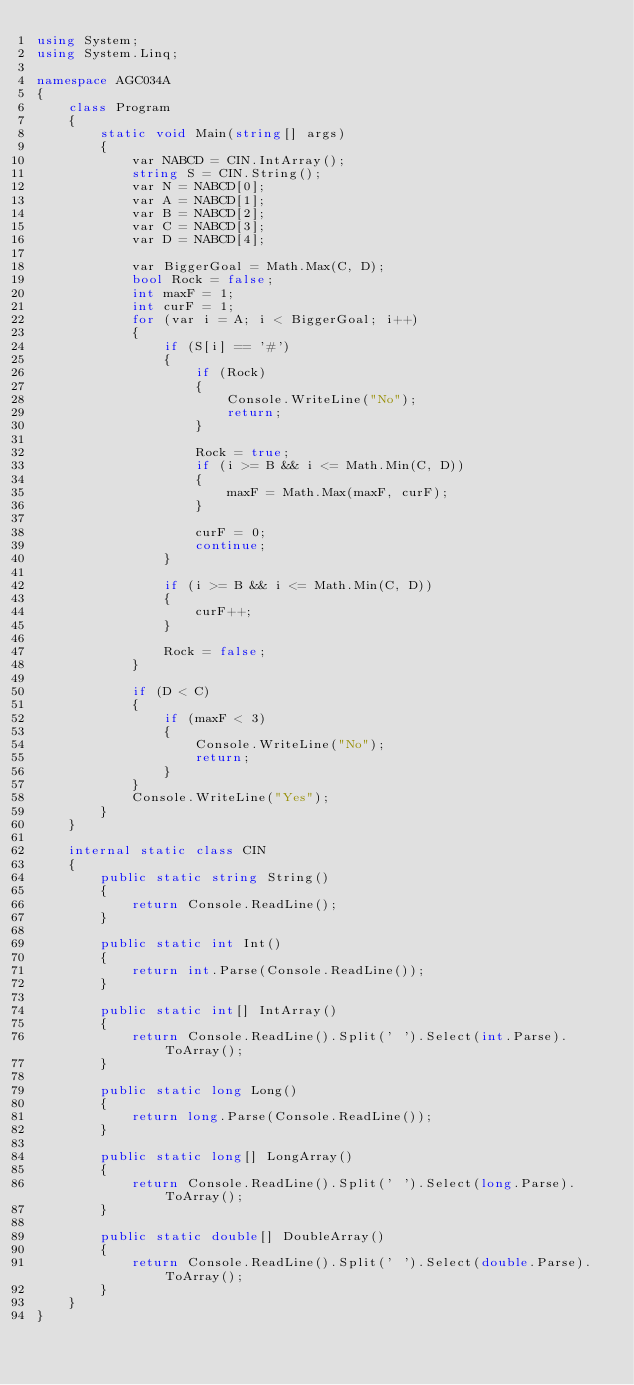Convert code to text. <code><loc_0><loc_0><loc_500><loc_500><_C#_>using System;
using System.Linq;

namespace AGC034A
{
    class Program
    {
        static void Main(string[] args)
        {
            var NABCD = CIN.IntArray();
            string S = CIN.String();
            var N = NABCD[0];
            var A = NABCD[1];
            var B = NABCD[2];
            var C = NABCD[3];
            var D = NABCD[4];

            var BiggerGoal = Math.Max(C, D);
            bool Rock = false;
            int maxF = 1;
            int curF = 1;
            for (var i = A; i < BiggerGoal; i++)
            {
                if (S[i] == '#')
                {
                    if (Rock)
                    {
                        Console.WriteLine("No");
                        return;
                    }

                    Rock = true;
                    if (i >= B && i <= Math.Min(C, D))
                    {
                        maxF = Math.Max(maxF, curF);
                    }

                    curF = 0;
                    continue;
                }

                if (i >= B && i <= Math.Min(C, D))
                {
                    curF++;
                }

                Rock = false;
            }

            if (D < C)
            {
                if (maxF < 3)
                {
                    Console.WriteLine("No");
                    return;
                }
            }
            Console.WriteLine("Yes");
        }
    }

    internal static class CIN
    {
        public static string String()
        {
            return Console.ReadLine();
        }

        public static int Int()
        {
            return int.Parse(Console.ReadLine());
        }

        public static int[] IntArray()
        {
            return Console.ReadLine().Split(' ').Select(int.Parse).ToArray();
        }

        public static long Long()
        {
            return long.Parse(Console.ReadLine());
        }

        public static long[] LongArray()
        {
            return Console.ReadLine().Split(' ').Select(long.Parse).ToArray();
        }

        public static double[] DoubleArray()
        {
            return Console.ReadLine().Split(' ').Select(double.Parse).ToArray();
        }
    }
}</code> 